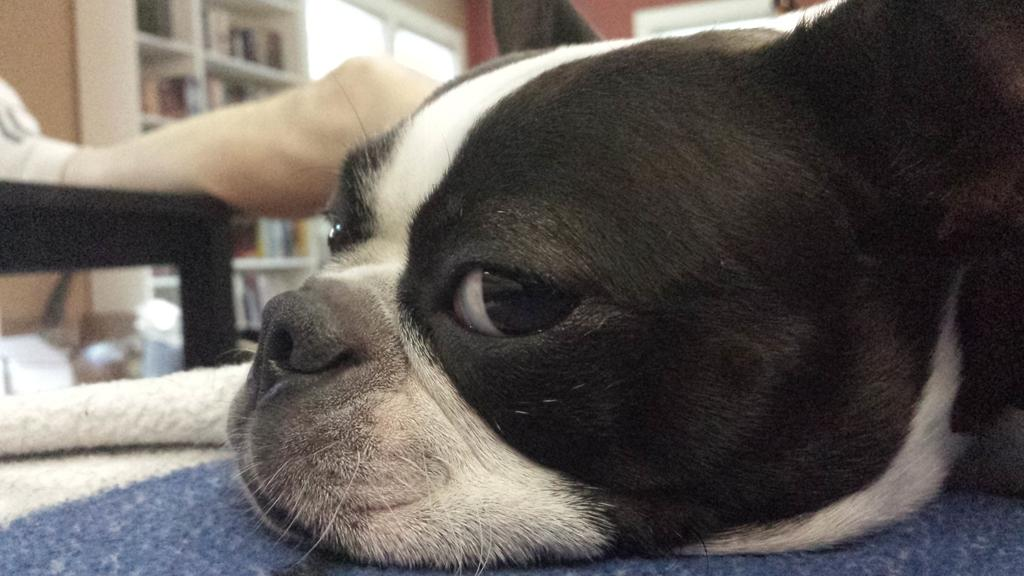What is the dog doing in the image? The dog is laying on the carpet. What part of a person is visible on the table? A person's leg is on the table. What can be seen on the shelves in the image? There are objects on shelves. What is the background of the image made up of? There is a wall in the image. Where is the nest located in the image? There is no nest present in the image. What type of feast is being prepared in the image? There is no feast being prepared in the image. 